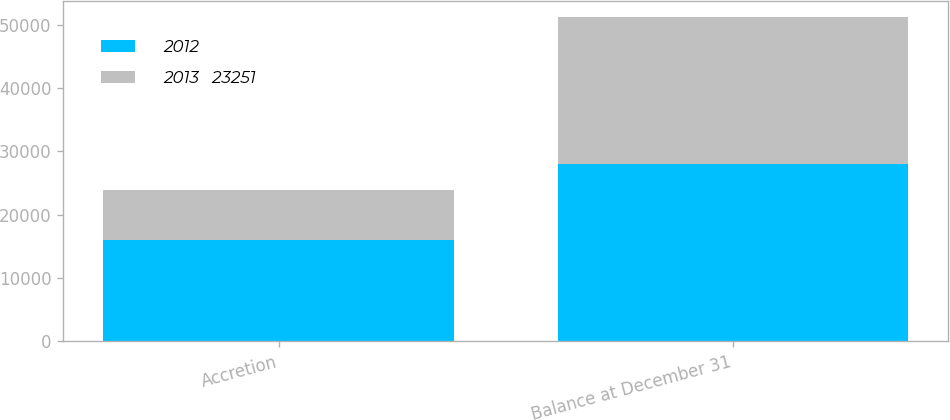Convert chart. <chart><loc_0><loc_0><loc_500><loc_500><stacked_bar_chart><ecel><fcel>Accretion<fcel>Balance at December 31<nl><fcel>2012<fcel>15931<fcel>27995<nl><fcel>2013   23251<fcel>7960<fcel>23251<nl></chart> 